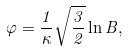<formula> <loc_0><loc_0><loc_500><loc_500>\varphi = \frac { 1 } { \kappa } \sqrt { \frac { 3 } { 2 } } \ln B ,</formula> 